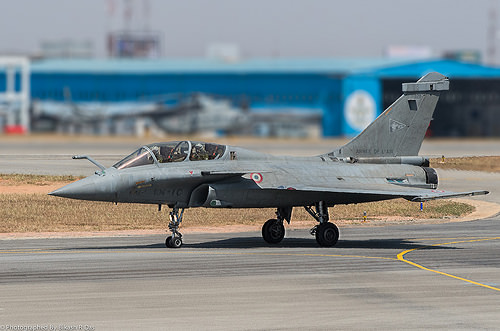<image>
Can you confirm if the plan is on the ground? Yes. Looking at the image, I can see the plan is positioned on top of the ground, with the ground providing support. 